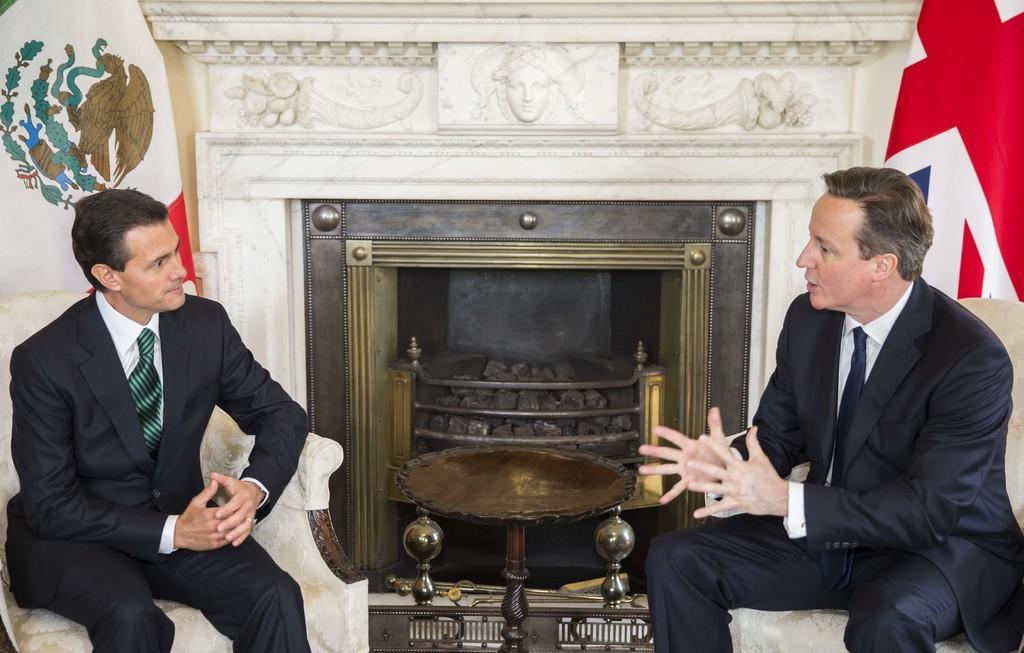In one or two sentences, can you explain what this image depicts? In the center of the image we can see two persons are sitting on the chairs and they are in different costumes. In the background there is a wall, sculpture, fireplace, stones, flags and a few other objects. And we can see some design on the wall. 